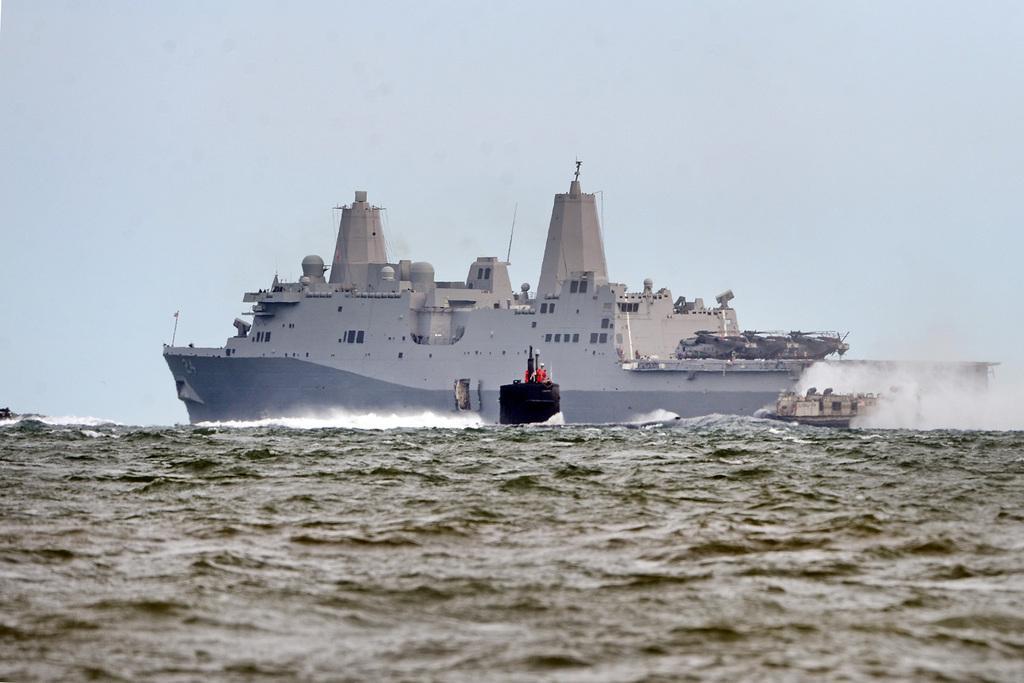In one or two sentences, can you explain what this image depicts? In the picture,there is a big ship sailing on the sea and beside the big ship there is a small boat. 